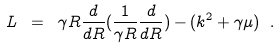Convert formula to latex. <formula><loc_0><loc_0><loc_500><loc_500>L \ = \ \gamma R \frac { d } { d R } ( \frac { 1 } { \gamma R } \frac { d } { d R } ) - ( k ^ { 2 } + \gamma \mu ) \ .</formula> 